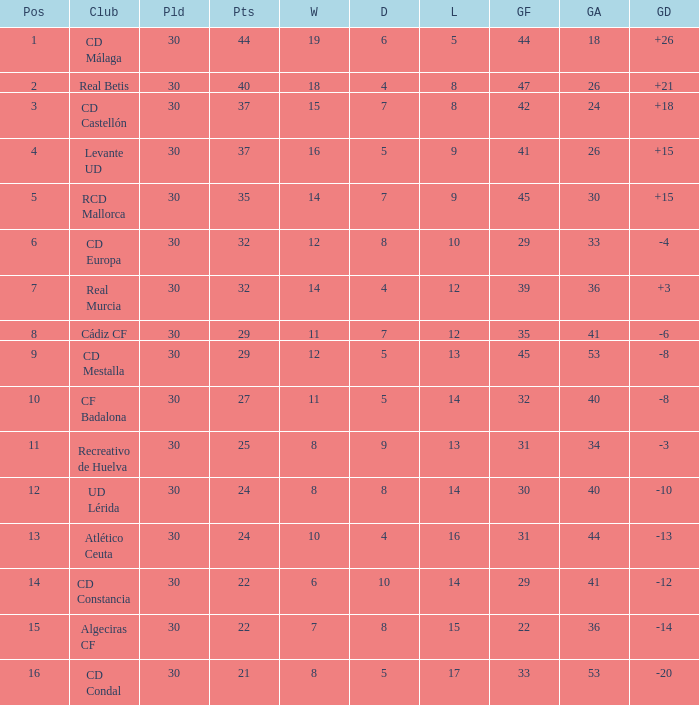Could you help me parse every detail presented in this table? {'header': ['Pos', 'Club', 'Pld', 'Pts', 'W', 'D', 'L', 'GF', 'GA', 'GD'], 'rows': [['1', 'CD Málaga', '30', '44', '19', '6', '5', '44', '18', '+26'], ['2', 'Real Betis', '30', '40', '18', '4', '8', '47', '26', '+21'], ['3', 'CD Castellón', '30', '37', '15', '7', '8', '42', '24', '+18'], ['4', 'Levante UD', '30', '37', '16', '5', '9', '41', '26', '+15'], ['5', 'RCD Mallorca', '30', '35', '14', '7', '9', '45', '30', '+15'], ['6', 'CD Europa', '30', '32', '12', '8', '10', '29', '33', '-4'], ['7', 'Real Murcia', '30', '32', '14', '4', '12', '39', '36', '+3'], ['8', 'Cádiz CF', '30', '29', '11', '7', '12', '35', '41', '-6'], ['9', 'CD Mestalla', '30', '29', '12', '5', '13', '45', '53', '-8'], ['10', 'CF Badalona', '30', '27', '11', '5', '14', '32', '40', '-8'], ['11', 'Recreativo de Huelva', '30', '25', '8', '9', '13', '31', '34', '-3'], ['12', 'UD Lérida', '30', '24', '8', '8', '14', '30', '40', '-10'], ['13', 'Atlético Ceuta', '30', '24', '10', '4', '16', '31', '44', '-13'], ['14', 'CD Constancia', '30', '22', '6', '10', '14', '29', '41', '-12'], ['15', 'Algeciras CF', '30', '22', '7', '8', '15', '22', '36', '-14'], ['16', 'CD Condal', '30', '21', '8', '5', '17', '33', '53', '-20']]} What is the number of wins when the goals against is larger than 41, points is 29, and draws are larger than 5? 0.0. 